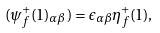Convert formula to latex. <formula><loc_0><loc_0><loc_500><loc_500>( \psi _ { f } ^ { + } ( { 1 } ) _ { \alpha \beta } ) = \epsilon _ { \alpha \beta } \eta _ { f } ^ { + } ( { 1 } ) ,</formula> 